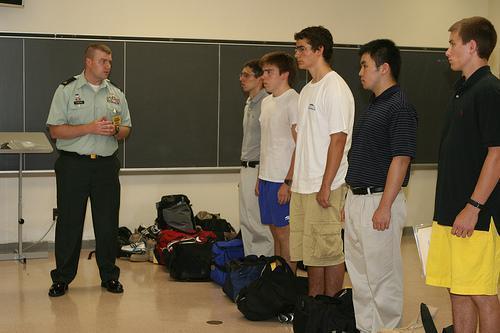How many men are there?
Give a very brief answer. 6. 